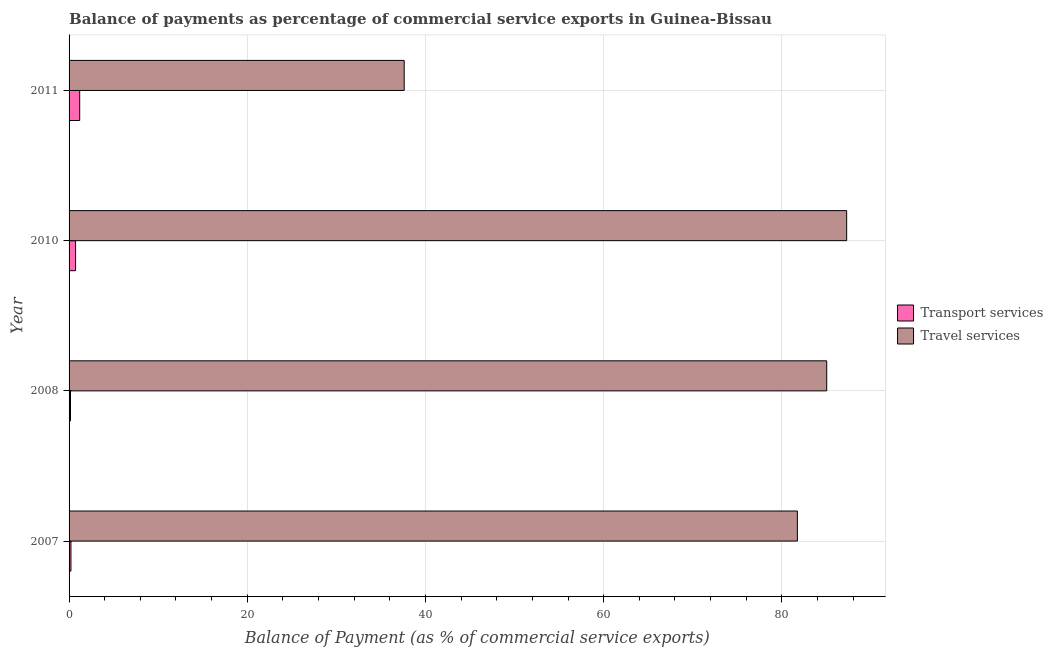How many different coloured bars are there?
Make the answer very short. 2. What is the balance of payments of travel services in 2011?
Ensure brevity in your answer.  37.61. Across all years, what is the maximum balance of payments of travel services?
Provide a succinct answer. 87.27. Across all years, what is the minimum balance of payments of travel services?
Your response must be concise. 37.61. In which year was the balance of payments of transport services maximum?
Make the answer very short. 2011. In which year was the balance of payments of travel services minimum?
Your answer should be very brief. 2011. What is the total balance of payments of travel services in the graph?
Your answer should be very brief. 291.67. What is the difference between the balance of payments of travel services in 2008 and that in 2010?
Provide a succinct answer. -2.24. What is the difference between the balance of payments of travel services in 2008 and the balance of payments of transport services in 2007?
Keep it short and to the point. 84.83. What is the average balance of payments of travel services per year?
Give a very brief answer. 72.92. In the year 2008, what is the difference between the balance of payments of travel services and balance of payments of transport services?
Make the answer very short. 84.88. What is the ratio of the balance of payments of travel services in 2008 to that in 2011?
Offer a terse response. 2.26. Is the balance of payments of travel services in 2007 less than that in 2010?
Your response must be concise. Yes. What is the difference between the highest and the second highest balance of payments of travel services?
Provide a short and direct response. 2.24. What is the difference between the highest and the lowest balance of payments of travel services?
Your answer should be compact. 49.66. In how many years, is the balance of payments of transport services greater than the average balance of payments of transport services taken over all years?
Keep it short and to the point. 2. Is the sum of the balance of payments of transport services in 2007 and 2010 greater than the maximum balance of payments of travel services across all years?
Give a very brief answer. No. What does the 1st bar from the top in 2011 represents?
Offer a terse response. Travel services. What does the 2nd bar from the bottom in 2011 represents?
Keep it short and to the point. Travel services. How many bars are there?
Offer a very short reply. 8. Are all the bars in the graph horizontal?
Your response must be concise. Yes. Are the values on the major ticks of X-axis written in scientific E-notation?
Keep it short and to the point. No. Does the graph contain any zero values?
Ensure brevity in your answer.  No. Does the graph contain grids?
Make the answer very short. Yes. Where does the legend appear in the graph?
Ensure brevity in your answer.  Center right. What is the title of the graph?
Provide a short and direct response. Balance of payments as percentage of commercial service exports in Guinea-Bissau. What is the label or title of the X-axis?
Your answer should be very brief. Balance of Payment (as % of commercial service exports). What is the label or title of the Y-axis?
Provide a succinct answer. Year. What is the Balance of Payment (as % of commercial service exports) in Transport services in 2007?
Make the answer very short. 0.21. What is the Balance of Payment (as % of commercial service exports) of Travel services in 2007?
Offer a very short reply. 81.74. What is the Balance of Payment (as % of commercial service exports) of Transport services in 2008?
Keep it short and to the point. 0.16. What is the Balance of Payment (as % of commercial service exports) of Travel services in 2008?
Keep it short and to the point. 85.04. What is the Balance of Payment (as % of commercial service exports) of Transport services in 2010?
Offer a terse response. 0.73. What is the Balance of Payment (as % of commercial service exports) of Travel services in 2010?
Provide a succinct answer. 87.27. What is the Balance of Payment (as % of commercial service exports) in Transport services in 2011?
Provide a succinct answer. 1.19. What is the Balance of Payment (as % of commercial service exports) of Travel services in 2011?
Offer a terse response. 37.61. Across all years, what is the maximum Balance of Payment (as % of commercial service exports) of Transport services?
Your answer should be compact. 1.19. Across all years, what is the maximum Balance of Payment (as % of commercial service exports) in Travel services?
Give a very brief answer. 87.27. Across all years, what is the minimum Balance of Payment (as % of commercial service exports) of Transport services?
Ensure brevity in your answer.  0.16. Across all years, what is the minimum Balance of Payment (as % of commercial service exports) in Travel services?
Offer a very short reply. 37.61. What is the total Balance of Payment (as % of commercial service exports) in Transport services in the graph?
Ensure brevity in your answer.  2.29. What is the total Balance of Payment (as % of commercial service exports) in Travel services in the graph?
Provide a succinct answer. 291.67. What is the difference between the Balance of Payment (as % of commercial service exports) in Transport services in 2007 and that in 2008?
Make the answer very short. 0.05. What is the difference between the Balance of Payment (as % of commercial service exports) in Travel services in 2007 and that in 2008?
Keep it short and to the point. -3.29. What is the difference between the Balance of Payment (as % of commercial service exports) in Transport services in 2007 and that in 2010?
Offer a very short reply. -0.52. What is the difference between the Balance of Payment (as % of commercial service exports) in Travel services in 2007 and that in 2010?
Make the answer very short. -5.53. What is the difference between the Balance of Payment (as % of commercial service exports) of Transport services in 2007 and that in 2011?
Ensure brevity in your answer.  -0.98. What is the difference between the Balance of Payment (as % of commercial service exports) of Travel services in 2007 and that in 2011?
Provide a short and direct response. 44.13. What is the difference between the Balance of Payment (as % of commercial service exports) in Transport services in 2008 and that in 2010?
Offer a terse response. -0.57. What is the difference between the Balance of Payment (as % of commercial service exports) of Travel services in 2008 and that in 2010?
Make the answer very short. -2.24. What is the difference between the Balance of Payment (as % of commercial service exports) of Transport services in 2008 and that in 2011?
Your response must be concise. -1.03. What is the difference between the Balance of Payment (as % of commercial service exports) in Travel services in 2008 and that in 2011?
Keep it short and to the point. 47.42. What is the difference between the Balance of Payment (as % of commercial service exports) of Transport services in 2010 and that in 2011?
Your answer should be very brief. -0.46. What is the difference between the Balance of Payment (as % of commercial service exports) in Travel services in 2010 and that in 2011?
Offer a terse response. 49.66. What is the difference between the Balance of Payment (as % of commercial service exports) in Transport services in 2007 and the Balance of Payment (as % of commercial service exports) in Travel services in 2008?
Provide a succinct answer. -84.83. What is the difference between the Balance of Payment (as % of commercial service exports) in Transport services in 2007 and the Balance of Payment (as % of commercial service exports) in Travel services in 2010?
Ensure brevity in your answer.  -87.06. What is the difference between the Balance of Payment (as % of commercial service exports) of Transport services in 2007 and the Balance of Payment (as % of commercial service exports) of Travel services in 2011?
Offer a very short reply. -37.4. What is the difference between the Balance of Payment (as % of commercial service exports) of Transport services in 2008 and the Balance of Payment (as % of commercial service exports) of Travel services in 2010?
Offer a terse response. -87.11. What is the difference between the Balance of Payment (as % of commercial service exports) of Transport services in 2008 and the Balance of Payment (as % of commercial service exports) of Travel services in 2011?
Offer a terse response. -37.45. What is the difference between the Balance of Payment (as % of commercial service exports) in Transport services in 2010 and the Balance of Payment (as % of commercial service exports) in Travel services in 2011?
Your answer should be very brief. -36.88. What is the average Balance of Payment (as % of commercial service exports) of Transport services per year?
Provide a short and direct response. 0.57. What is the average Balance of Payment (as % of commercial service exports) of Travel services per year?
Your answer should be very brief. 72.92. In the year 2007, what is the difference between the Balance of Payment (as % of commercial service exports) in Transport services and Balance of Payment (as % of commercial service exports) in Travel services?
Your response must be concise. -81.53. In the year 2008, what is the difference between the Balance of Payment (as % of commercial service exports) in Transport services and Balance of Payment (as % of commercial service exports) in Travel services?
Provide a short and direct response. -84.88. In the year 2010, what is the difference between the Balance of Payment (as % of commercial service exports) of Transport services and Balance of Payment (as % of commercial service exports) of Travel services?
Keep it short and to the point. -86.54. In the year 2011, what is the difference between the Balance of Payment (as % of commercial service exports) in Transport services and Balance of Payment (as % of commercial service exports) in Travel services?
Your answer should be compact. -36.42. What is the ratio of the Balance of Payment (as % of commercial service exports) in Transport services in 2007 to that in 2008?
Offer a very short reply. 1.31. What is the ratio of the Balance of Payment (as % of commercial service exports) of Travel services in 2007 to that in 2008?
Offer a very short reply. 0.96. What is the ratio of the Balance of Payment (as % of commercial service exports) in Transport services in 2007 to that in 2010?
Your answer should be compact. 0.29. What is the ratio of the Balance of Payment (as % of commercial service exports) in Travel services in 2007 to that in 2010?
Ensure brevity in your answer.  0.94. What is the ratio of the Balance of Payment (as % of commercial service exports) in Transport services in 2007 to that in 2011?
Provide a short and direct response. 0.18. What is the ratio of the Balance of Payment (as % of commercial service exports) of Travel services in 2007 to that in 2011?
Make the answer very short. 2.17. What is the ratio of the Balance of Payment (as % of commercial service exports) in Transport services in 2008 to that in 2010?
Provide a short and direct response. 0.22. What is the ratio of the Balance of Payment (as % of commercial service exports) in Travel services in 2008 to that in 2010?
Offer a very short reply. 0.97. What is the ratio of the Balance of Payment (as % of commercial service exports) in Transport services in 2008 to that in 2011?
Make the answer very short. 0.13. What is the ratio of the Balance of Payment (as % of commercial service exports) of Travel services in 2008 to that in 2011?
Your response must be concise. 2.26. What is the ratio of the Balance of Payment (as % of commercial service exports) of Transport services in 2010 to that in 2011?
Provide a succinct answer. 0.61. What is the ratio of the Balance of Payment (as % of commercial service exports) in Travel services in 2010 to that in 2011?
Provide a short and direct response. 2.32. What is the difference between the highest and the second highest Balance of Payment (as % of commercial service exports) in Transport services?
Offer a terse response. 0.46. What is the difference between the highest and the second highest Balance of Payment (as % of commercial service exports) in Travel services?
Give a very brief answer. 2.24. What is the difference between the highest and the lowest Balance of Payment (as % of commercial service exports) in Transport services?
Keep it short and to the point. 1.03. What is the difference between the highest and the lowest Balance of Payment (as % of commercial service exports) of Travel services?
Offer a terse response. 49.66. 